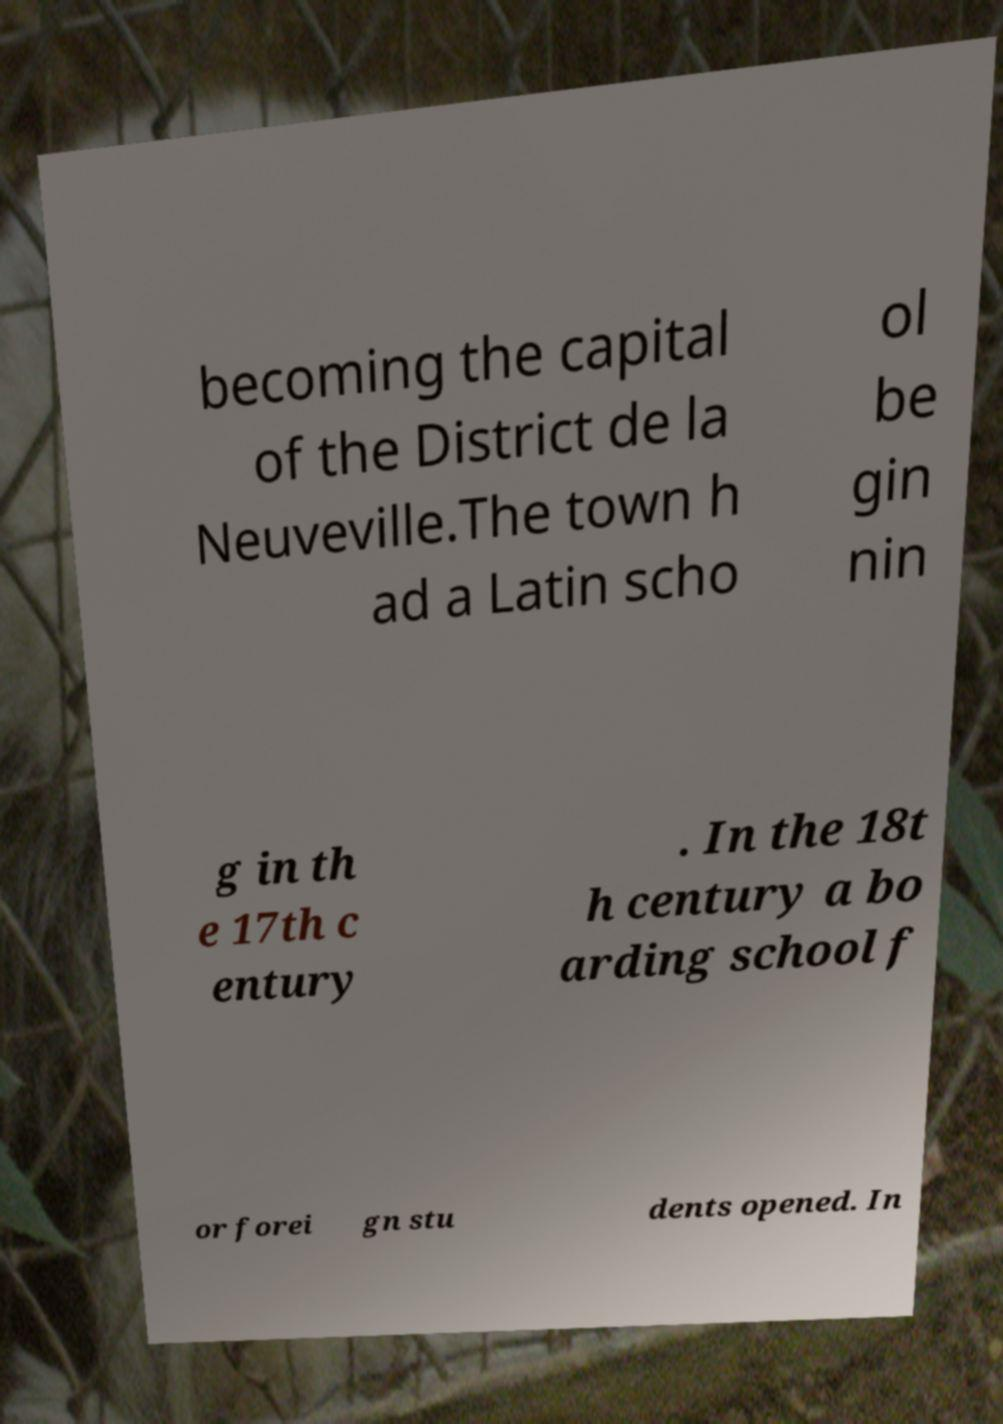Please identify and transcribe the text found in this image. becoming the capital of the District de la Neuveville.The town h ad a Latin scho ol be gin nin g in th e 17th c entury . In the 18t h century a bo arding school f or forei gn stu dents opened. In 